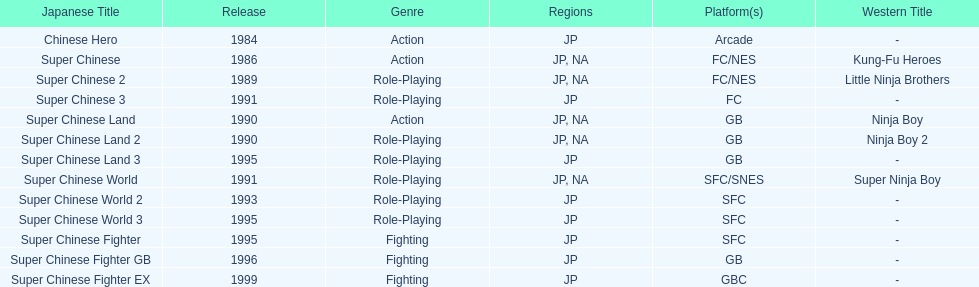Can you give me this table as a dict? {'header': ['Japanese Title', 'Release', 'Genre', 'Regions', 'Platform(s)', 'Western Title'], 'rows': [['Chinese Hero', '1984', 'Action', 'JP', 'Arcade', '-'], ['Super Chinese', '1986', 'Action', 'JP, NA', 'FC/NES', 'Kung-Fu Heroes'], ['Super Chinese 2', '1989', 'Role-Playing', 'JP, NA', 'FC/NES', 'Little Ninja Brothers'], ['Super Chinese 3', '1991', 'Role-Playing', 'JP', 'FC', '-'], ['Super Chinese Land', '1990', 'Action', 'JP, NA', 'GB', 'Ninja Boy'], ['Super Chinese Land 2', '1990', 'Role-Playing', 'JP, NA', 'GB', 'Ninja Boy 2'], ['Super Chinese Land 3', '1995', 'Role-Playing', 'JP', 'GB', '-'], ['Super Chinese World', '1991', 'Role-Playing', 'JP, NA', 'SFC/SNES', 'Super Ninja Boy'], ['Super Chinese World 2', '1993', 'Role-Playing', 'JP', 'SFC', '-'], ['Super Chinese World 3', '1995', 'Role-Playing', 'JP', 'SFC', '-'], ['Super Chinese Fighter', '1995', 'Fighting', 'JP', 'SFC', '-'], ['Super Chinese Fighter GB', '1996', 'Fighting', 'JP', 'GB', '-'], ['Super Chinese Fighter EX', '1999', 'Fighting', 'JP', 'GBC', '-']]} How many action games have been introduced in north america? 2. 